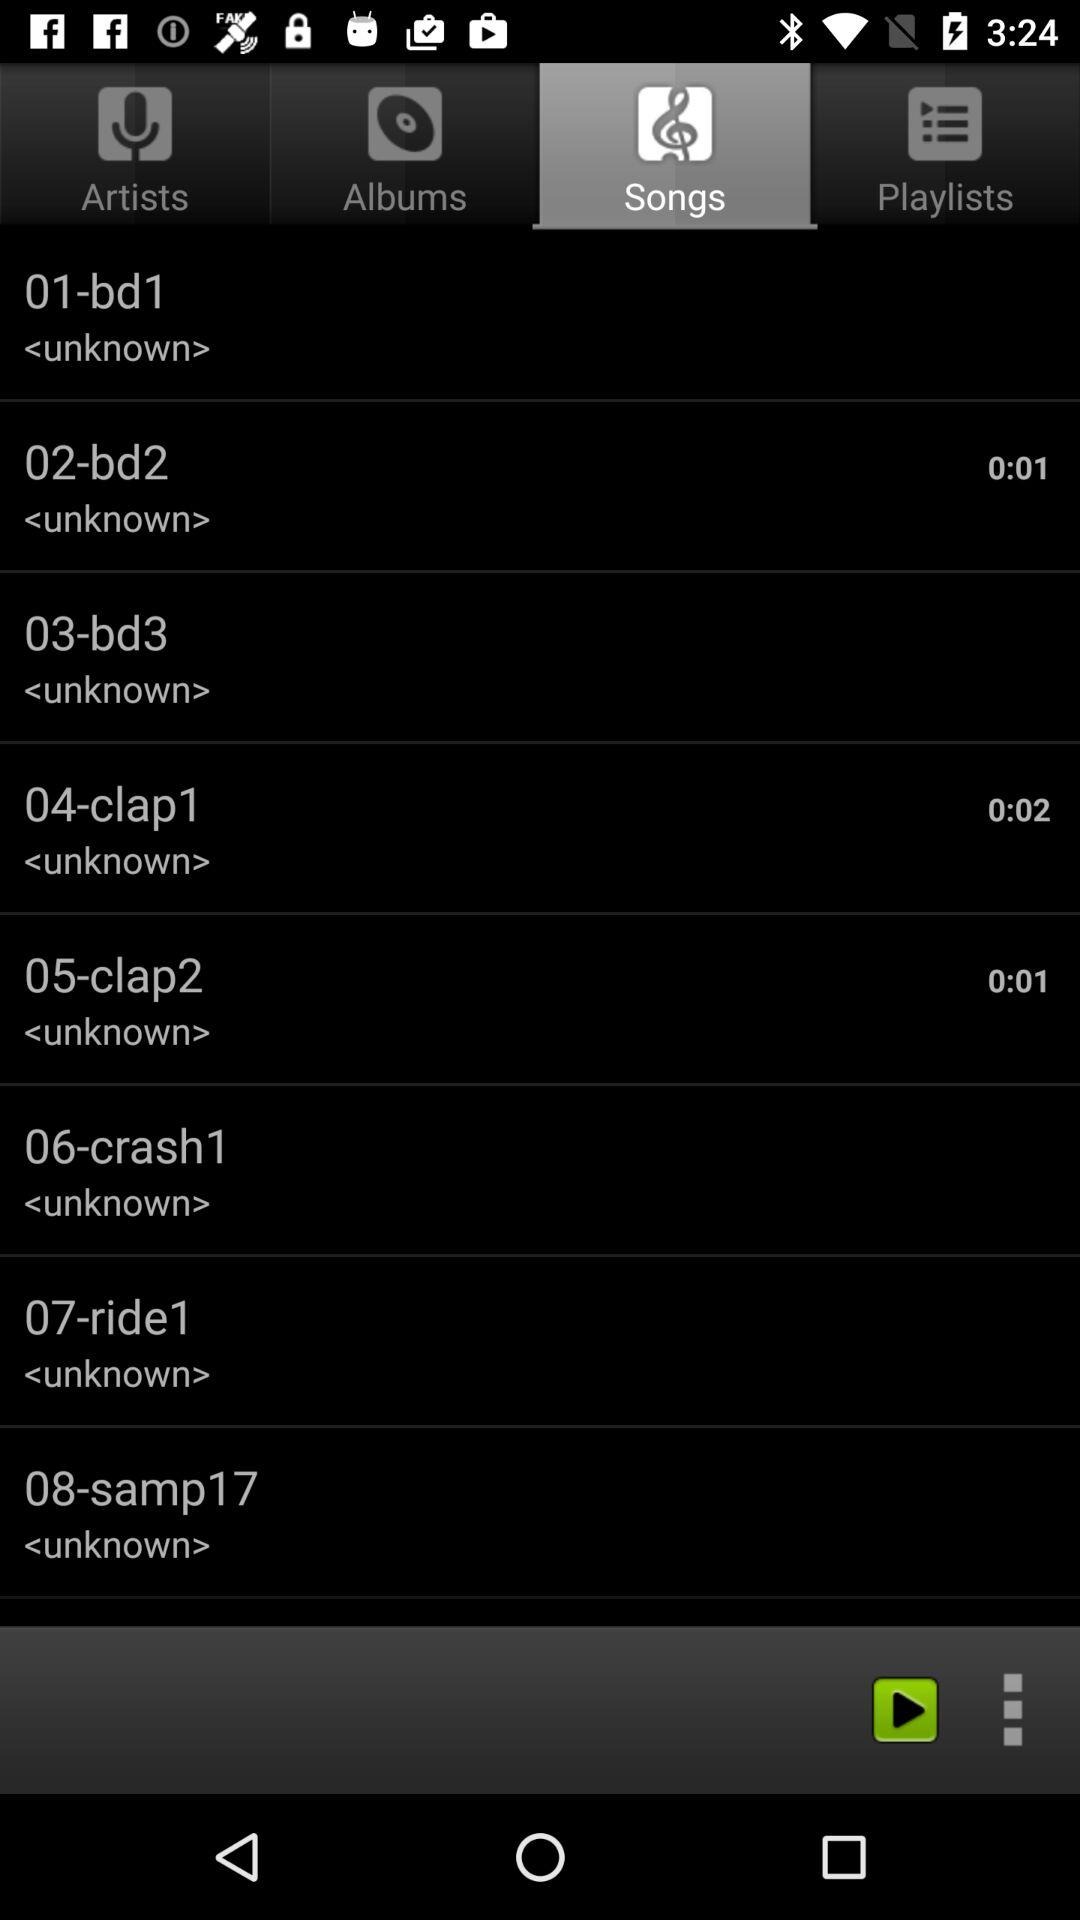Which tab is open? The tab "Songs" is open. 